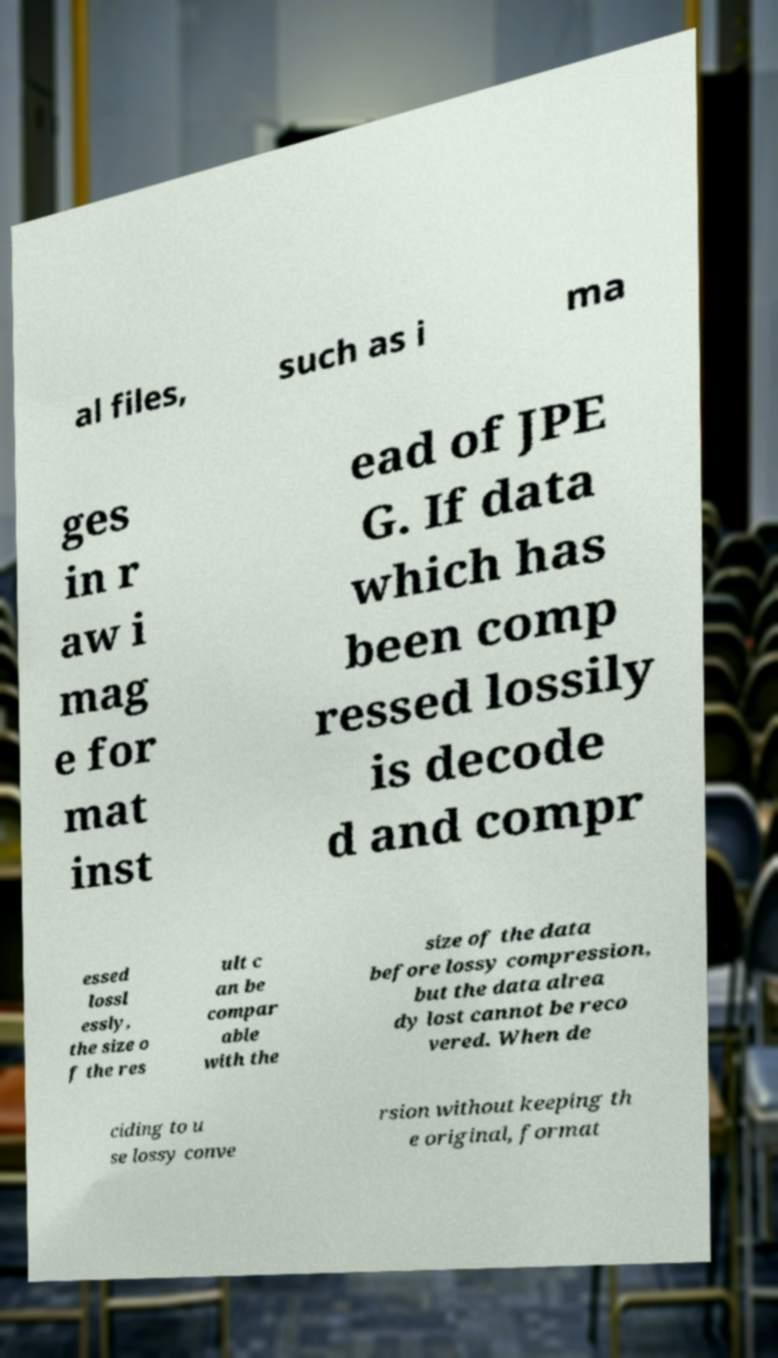Please read and relay the text visible in this image. What does it say? al files, such as i ma ges in r aw i mag e for mat inst ead of JPE G. If data which has been comp ressed lossily is decode d and compr essed lossl essly, the size o f the res ult c an be compar able with the size of the data before lossy compression, but the data alrea dy lost cannot be reco vered. When de ciding to u se lossy conve rsion without keeping th e original, format 